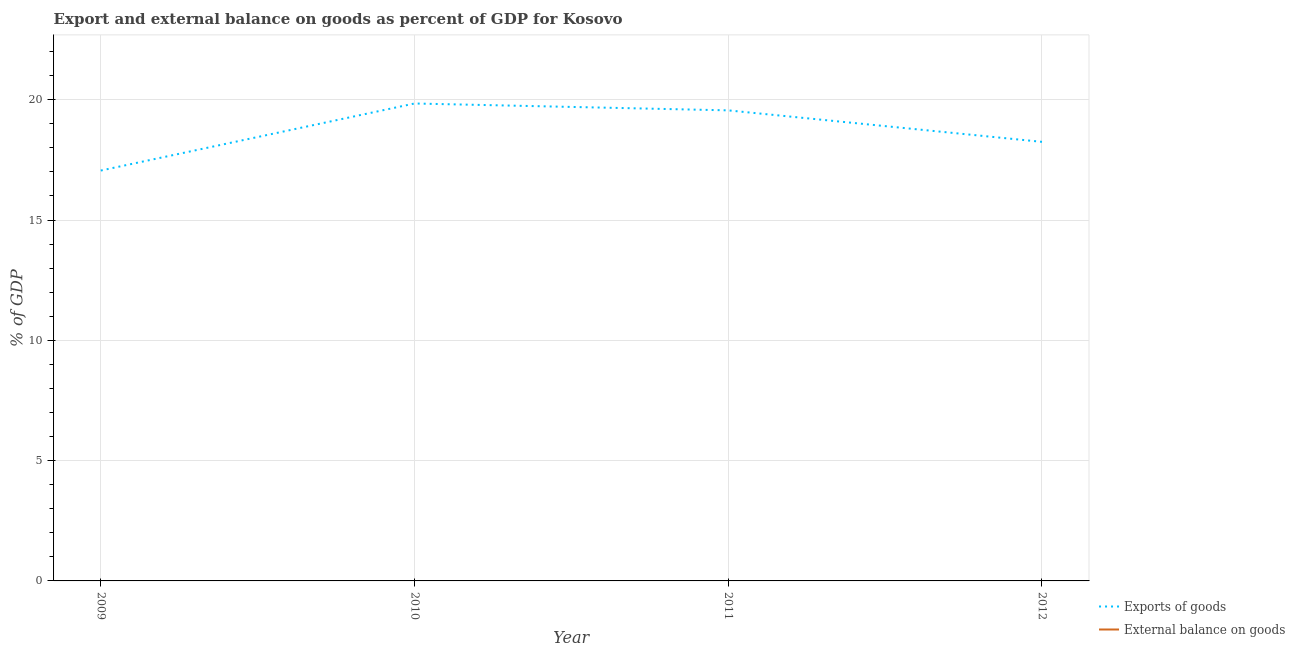What is the export of goods as percentage of gdp in 2011?
Offer a terse response. 19.56. Across all years, what is the maximum export of goods as percentage of gdp?
Make the answer very short. 19.85. Across all years, what is the minimum external balance on goods as percentage of gdp?
Your response must be concise. 0. What is the total external balance on goods as percentage of gdp in the graph?
Ensure brevity in your answer.  0. What is the difference between the export of goods as percentage of gdp in 2009 and that in 2012?
Give a very brief answer. -1.19. What is the difference between the export of goods as percentage of gdp in 2010 and the external balance on goods as percentage of gdp in 2012?
Offer a very short reply. 19.85. What is the average external balance on goods as percentage of gdp per year?
Keep it short and to the point. 0. What is the ratio of the export of goods as percentage of gdp in 2010 to that in 2012?
Your answer should be very brief. 1.09. Is the export of goods as percentage of gdp in 2010 less than that in 2011?
Provide a succinct answer. No. What is the difference between the highest and the second highest export of goods as percentage of gdp?
Your answer should be compact. 0.29. What is the difference between the highest and the lowest export of goods as percentage of gdp?
Provide a short and direct response. 2.79. In how many years, is the export of goods as percentage of gdp greater than the average export of goods as percentage of gdp taken over all years?
Your response must be concise. 2. Is the sum of the export of goods as percentage of gdp in 2011 and 2012 greater than the maximum external balance on goods as percentage of gdp across all years?
Your response must be concise. Yes. Does the export of goods as percentage of gdp monotonically increase over the years?
Your response must be concise. No. How many lines are there?
Your answer should be compact. 1. How many legend labels are there?
Provide a succinct answer. 2. How are the legend labels stacked?
Keep it short and to the point. Vertical. What is the title of the graph?
Your answer should be compact. Export and external balance on goods as percent of GDP for Kosovo. Does "Investment in Transport" appear as one of the legend labels in the graph?
Your answer should be very brief. No. What is the label or title of the X-axis?
Offer a terse response. Year. What is the label or title of the Y-axis?
Ensure brevity in your answer.  % of GDP. What is the % of GDP in Exports of goods in 2009?
Offer a terse response. 17.06. What is the % of GDP of External balance on goods in 2009?
Offer a terse response. 0. What is the % of GDP of Exports of goods in 2010?
Give a very brief answer. 19.85. What is the % of GDP in Exports of goods in 2011?
Provide a short and direct response. 19.56. What is the % of GDP in External balance on goods in 2011?
Your answer should be very brief. 0. What is the % of GDP of Exports of goods in 2012?
Your response must be concise. 18.25. Across all years, what is the maximum % of GDP in Exports of goods?
Provide a succinct answer. 19.85. Across all years, what is the minimum % of GDP in Exports of goods?
Offer a terse response. 17.06. What is the total % of GDP in Exports of goods in the graph?
Your answer should be compact. 74.71. What is the total % of GDP in External balance on goods in the graph?
Your response must be concise. 0. What is the difference between the % of GDP in Exports of goods in 2009 and that in 2010?
Keep it short and to the point. -2.79. What is the difference between the % of GDP in Exports of goods in 2009 and that in 2011?
Ensure brevity in your answer.  -2.5. What is the difference between the % of GDP of Exports of goods in 2009 and that in 2012?
Your answer should be very brief. -1.19. What is the difference between the % of GDP in Exports of goods in 2010 and that in 2011?
Provide a short and direct response. 0.29. What is the difference between the % of GDP of Exports of goods in 2010 and that in 2012?
Offer a terse response. 1.59. What is the difference between the % of GDP of Exports of goods in 2011 and that in 2012?
Your answer should be very brief. 1.31. What is the average % of GDP of Exports of goods per year?
Keep it short and to the point. 18.68. What is the average % of GDP of External balance on goods per year?
Your response must be concise. 0. What is the ratio of the % of GDP of Exports of goods in 2009 to that in 2010?
Your answer should be very brief. 0.86. What is the ratio of the % of GDP of Exports of goods in 2009 to that in 2011?
Your response must be concise. 0.87. What is the ratio of the % of GDP of Exports of goods in 2009 to that in 2012?
Provide a succinct answer. 0.93. What is the ratio of the % of GDP in Exports of goods in 2010 to that in 2011?
Your answer should be very brief. 1.01. What is the ratio of the % of GDP in Exports of goods in 2010 to that in 2012?
Keep it short and to the point. 1.09. What is the ratio of the % of GDP of Exports of goods in 2011 to that in 2012?
Your response must be concise. 1.07. What is the difference between the highest and the second highest % of GDP of Exports of goods?
Ensure brevity in your answer.  0.29. What is the difference between the highest and the lowest % of GDP in Exports of goods?
Make the answer very short. 2.79. 